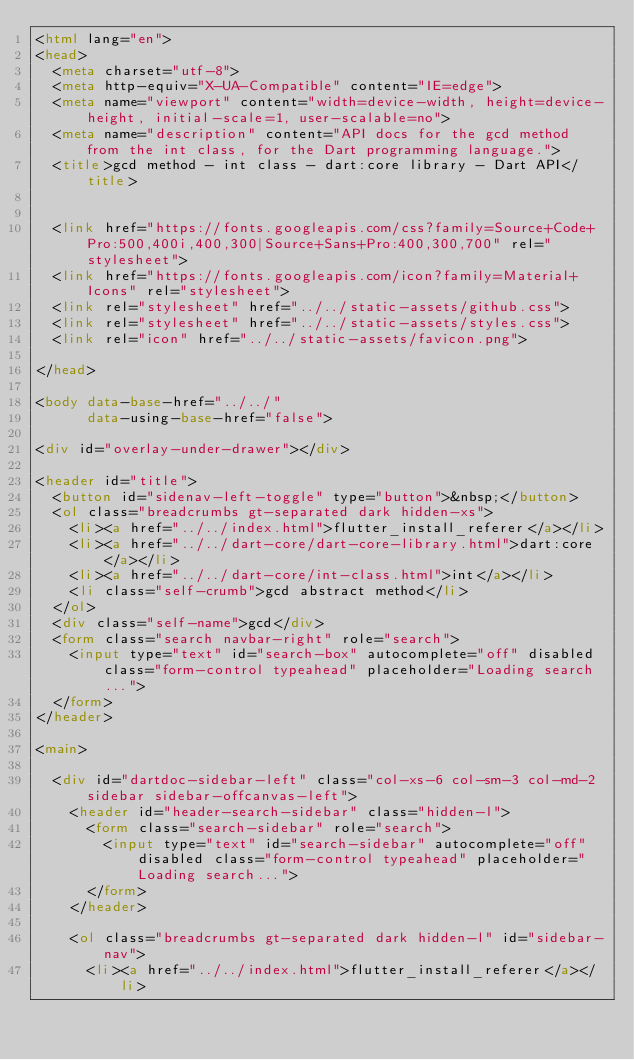<code> <loc_0><loc_0><loc_500><loc_500><_HTML_><html lang="en">
<head>
  <meta charset="utf-8">
  <meta http-equiv="X-UA-Compatible" content="IE=edge">
  <meta name="viewport" content="width=device-width, height=device-height, initial-scale=1, user-scalable=no">
  <meta name="description" content="API docs for the gcd method from the int class, for the Dart programming language.">
  <title>gcd method - int class - dart:core library - Dart API</title>

  
  <link href="https://fonts.googleapis.com/css?family=Source+Code+Pro:500,400i,400,300|Source+Sans+Pro:400,300,700" rel="stylesheet">
  <link href="https://fonts.googleapis.com/icon?family=Material+Icons" rel="stylesheet">
  <link rel="stylesheet" href="../../static-assets/github.css">
  <link rel="stylesheet" href="../../static-assets/styles.css">
  <link rel="icon" href="../../static-assets/favicon.png">

</head>

<body data-base-href="../../"
      data-using-base-href="false">

<div id="overlay-under-drawer"></div>

<header id="title">
  <button id="sidenav-left-toggle" type="button">&nbsp;</button>
  <ol class="breadcrumbs gt-separated dark hidden-xs">
    <li><a href="../../index.html">flutter_install_referer</a></li>
    <li><a href="../../dart-core/dart-core-library.html">dart:core</a></li>
    <li><a href="../../dart-core/int-class.html">int</a></li>
    <li class="self-crumb">gcd abstract method</li>
  </ol>
  <div class="self-name">gcd</div>
  <form class="search navbar-right" role="search">
    <input type="text" id="search-box" autocomplete="off" disabled class="form-control typeahead" placeholder="Loading search...">
  </form>
</header>

<main>

  <div id="dartdoc-sidebar-left" class="col-xs-6 col-sm-3 col-md-2 sidebar sidebar-offcanvas-left">
    <header id="header-search-sidebar" class="hidden-l">
      <form class="search-sidebar" role="search">
        <input type="text" id="search-sidebar" autocomplete="off" disabled class="form-control typeahead" placeholder="Loading search...">
      </form>
    </header>
    
    <ol class="breadcrumbs gt-separated dark hidden-l" id="sidebar-nav">
      <li><a href="../../index.html">flutter_install_referer</a></li></code> 